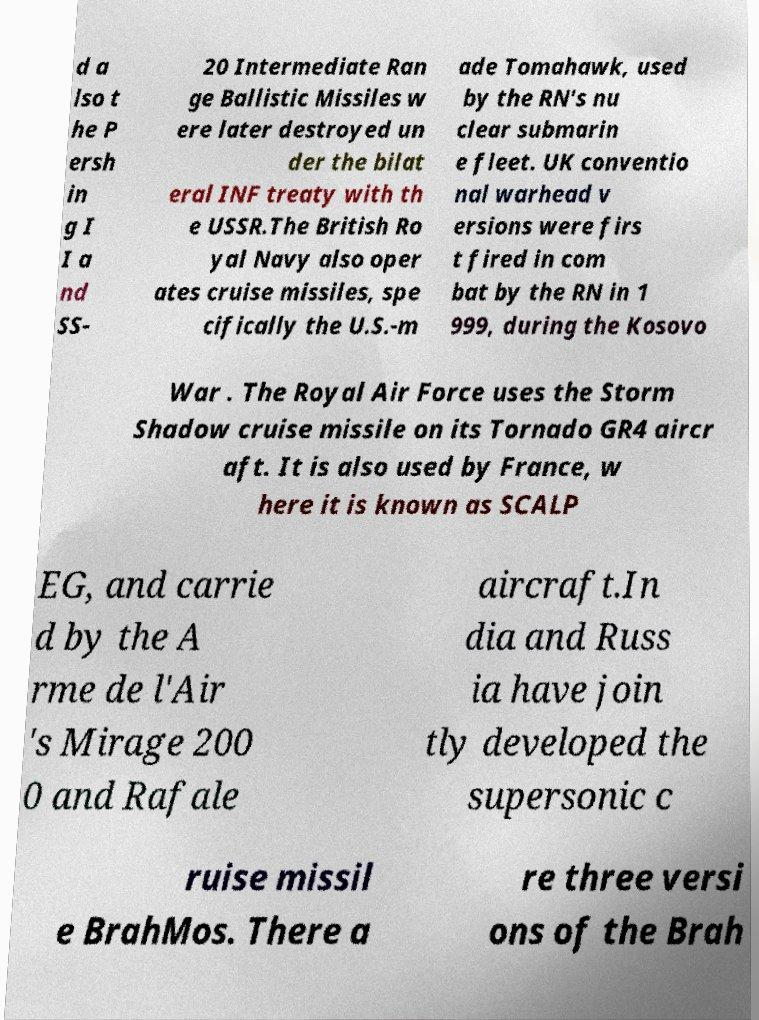Could you extract and type out the text from this image? d a lso t he P ersh in g I I a nd SS- 20 Intermediate Ran ge Ballistic Missiles w ere later destroyed un der the bilat eral INF treaty with th e USSR.The British Ro yal Navy also oper ates cruise missiles, spe cifically the U.S.-m ade Tomahawk, used by the RN's nu clear submarin e fleet. UK conventio nal warhead v ersions were firs t fired in com bat by the RN in 1 999, during the Kosovo War . The Royal Air Force uses the Storm Shadow cruise missile on its Tornado GR4 aircr aft. It is also used by France, w here it is known as SCALP EG, and carrie d by the A rme de l'Air 's Mirage 200 0 and Rafale aircraft.In dia and Russ ia have join tly developed the supersonic c ruise missil e BrahMos. There a re three versi ons of the Brah 